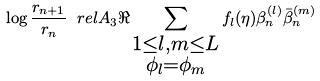<formula> <loc_0><loc_0><loc_500><loc_500>\log \frac { r _ { n + 1 } } { r _ { n } } \ r e l { A _ { 3 } } \Re \sum _ { \substack { 1 \leq l , m \leq L \\ \phi _ { l } = \phi _ { m } } } f _ { l } ( \eta ) \beta _ { n } ^ { ( l ) } \bar { \beta } _ { n } ^ { ( m ) }</formula> 